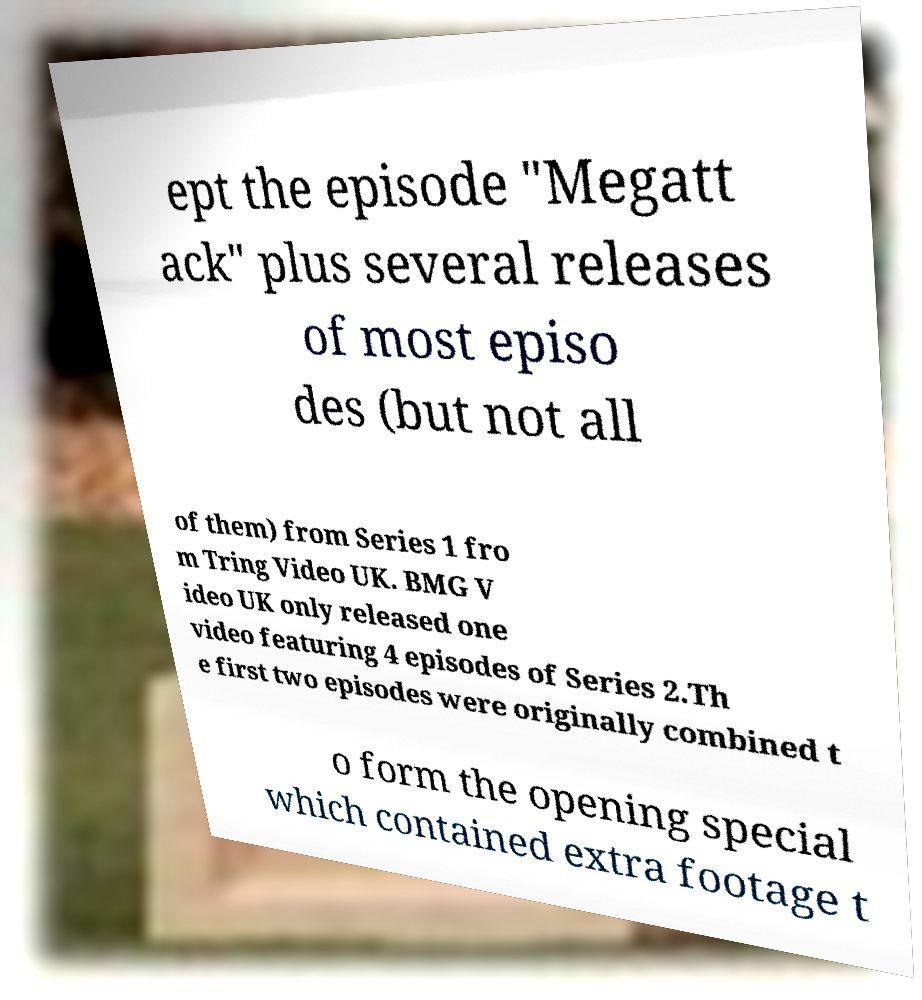Could you assist in decoding the text presented in this image and type it out clearly? ept the episode "Megatt ack" plus several releases of most episo des (but not all of them) from Series 1 fro m Tring Video UK. BMG V ideo UK only released one video featuring 4 episodes of Series 2.Th e first two episodes were originally combined t o form the opening special which contained extra footage t 